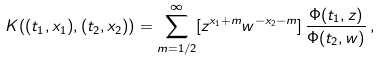Convert formula to latex. <formula><loc_0><loc_0><loc_500><loc_500>K ( ( t _ { 1 } , x _ { 1 } ) , ( t _ { 2 } , x _ { 2 } ) ) = \sum _ { m = 1 / 2 } ^ { \infty } [ z ^ { x _ { 1 } + m } w ^ { - x _ { 2 } - m } ] \, \frac { \Phi ( t _ { 1 } , z ) } { \Phi ( t _ { 2 } , w ) } \, ,</formula> 